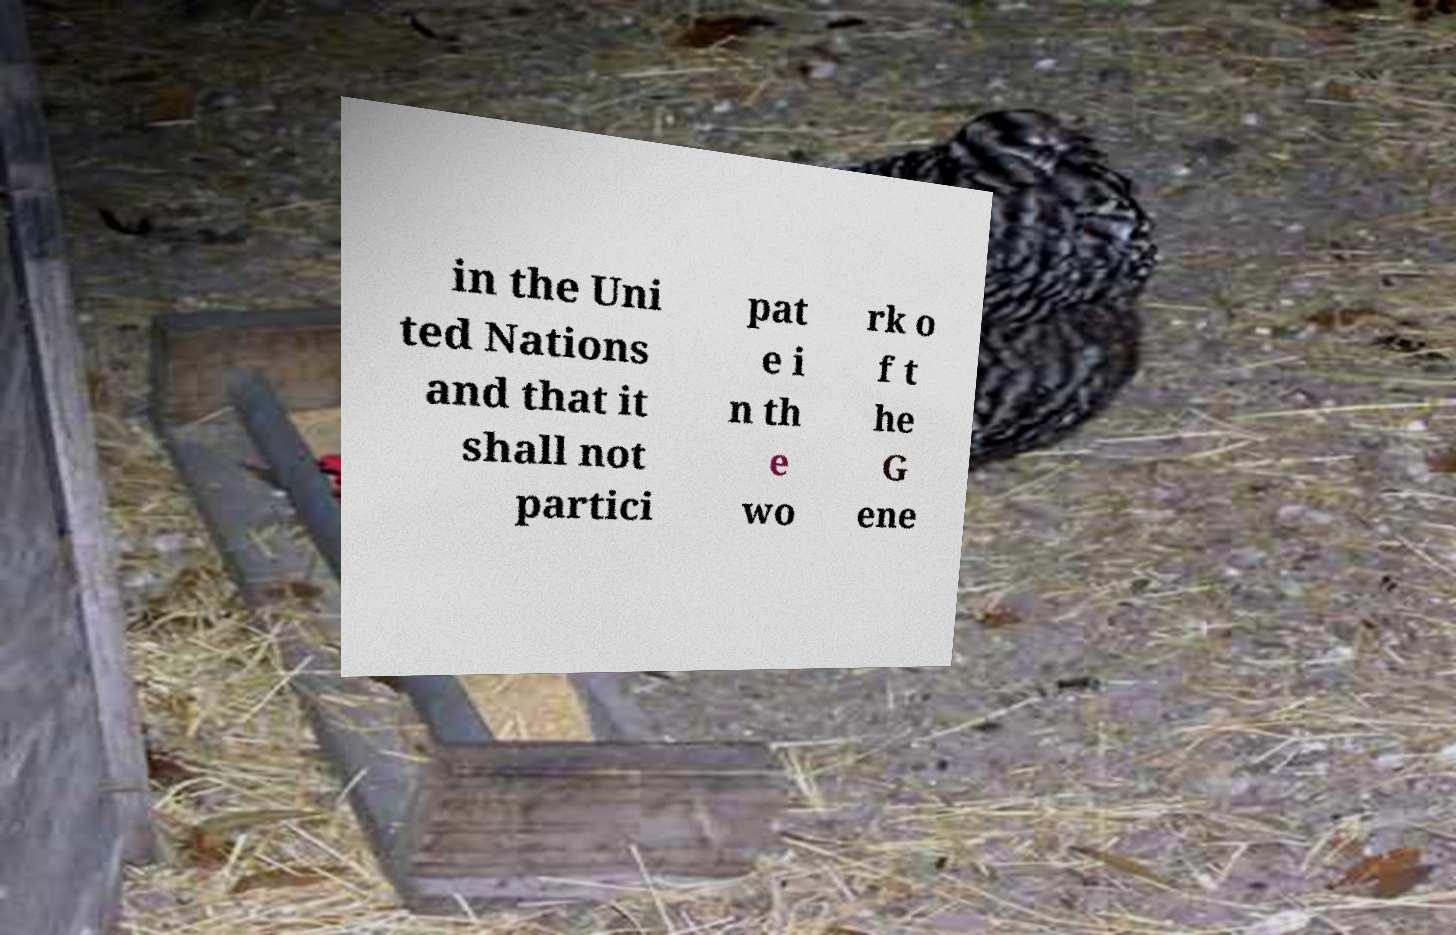Could you assist in decoding the text presented in this image and type it out clearly? in the Uni ted Nations and that it shall not partici pat e i n th e wo rk o f t he G ene 